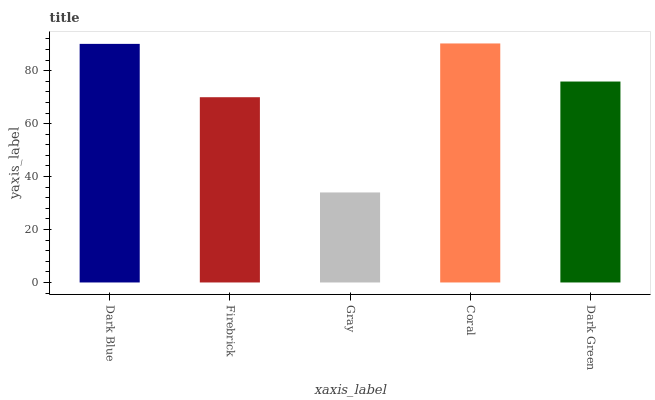Is Gray the minimum?
Answer yes or no. Yes. Is Coral the maximum?
Answer yes or no. Yes. Is Firebrick the minimum?
Answer yes or no. No. Is Firebrick the maximum?
Answer yes or no. No. Is Dark Blue greater than Firebrick?
Answer yes or no. Yes. Is Firebrick less than Dark Blue?
Answer yes or no. Yes. Is Firebrick greater than Dark Blue?
Answer yes or no. No. Is Dark Blue less than Firebrick?
Answer yes or no. No. Is Dark Green the high median?
Answer yes or no. Yes. Is Dark Green the low median?
Answer yes or no. Yes. Is Dark Blue the high median?
Answer yes or no. No. Is Gray the low median?
Answer yes or no. No. 